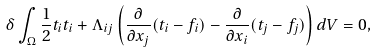Convert formula to latex. <formula><loc_0><loc_0><loc_500><loc_500>\delta \int _ { \Omega } \frac { 1 } { 2 } t _ { i } t _ { i } + \Lambda _ { i j } \left ( \frac { \partial } { \partial x _ { j } } ( t _ { i } - f _ { i } ) - \frac { \partial } { \partial x _ { i } } ( t _ { j } - f _ { j } ) \right ) d V = 0 ,</formula> 